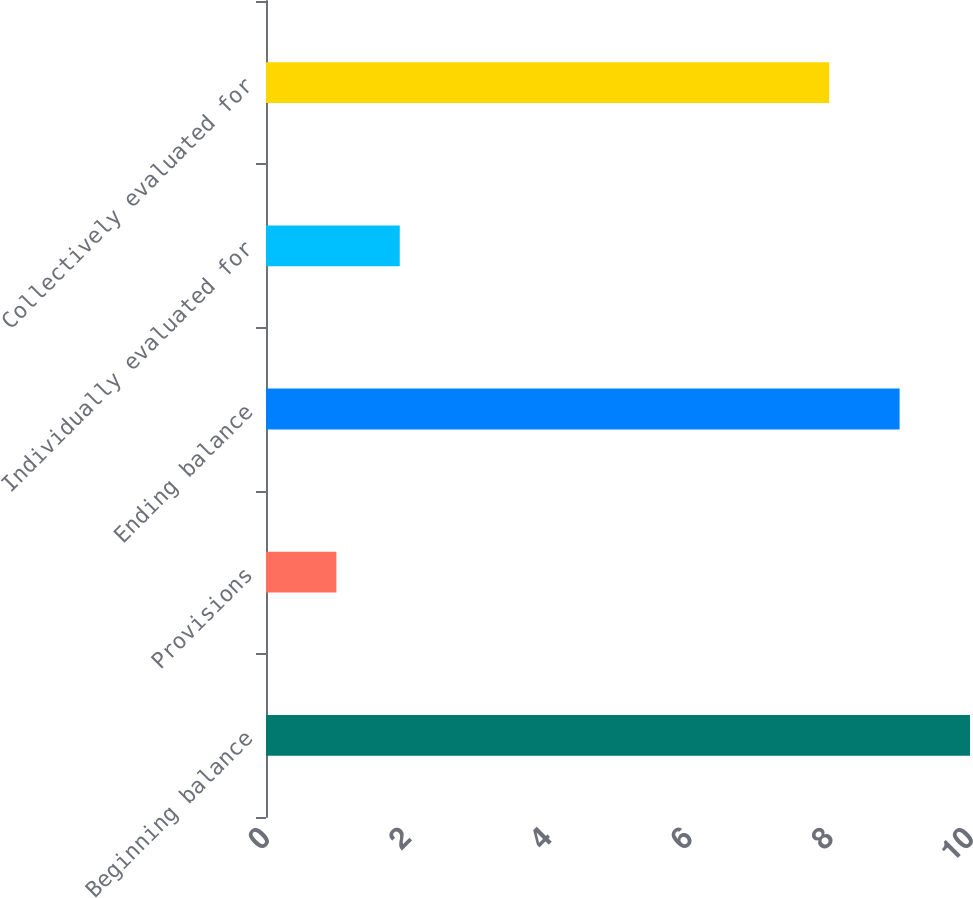Convert chart to OTSL. <chart><loc_0><loc_0><loc_500><loc_500><bar_chart><fcel>Beginning balance<fcel>Provisions<fcel>Ending balance<fcel>Individually evaluated for<fcel>Collectively evaluated for<nl><fcel>10<fcel>1<fcel>9<fcel>1.9<fcel>8<nl></chart> 